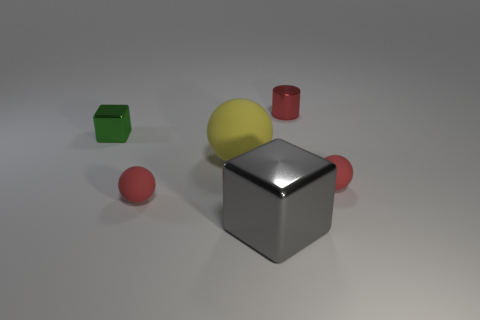Add 2 large gray metal objects. How many objects exist? 8 Subtract all cylinders. How many objects are left? 5 Add 2 blue rubber cubes. How many blue rubber cubes exist? 2 Subtract 0 purple cylinders. How many objects are left? 6 Subtract all small gray things. Subtract all tiny objects. How many objects are left? 2 Add 2 yellow spheres. How many yellow spheres are left? 3 